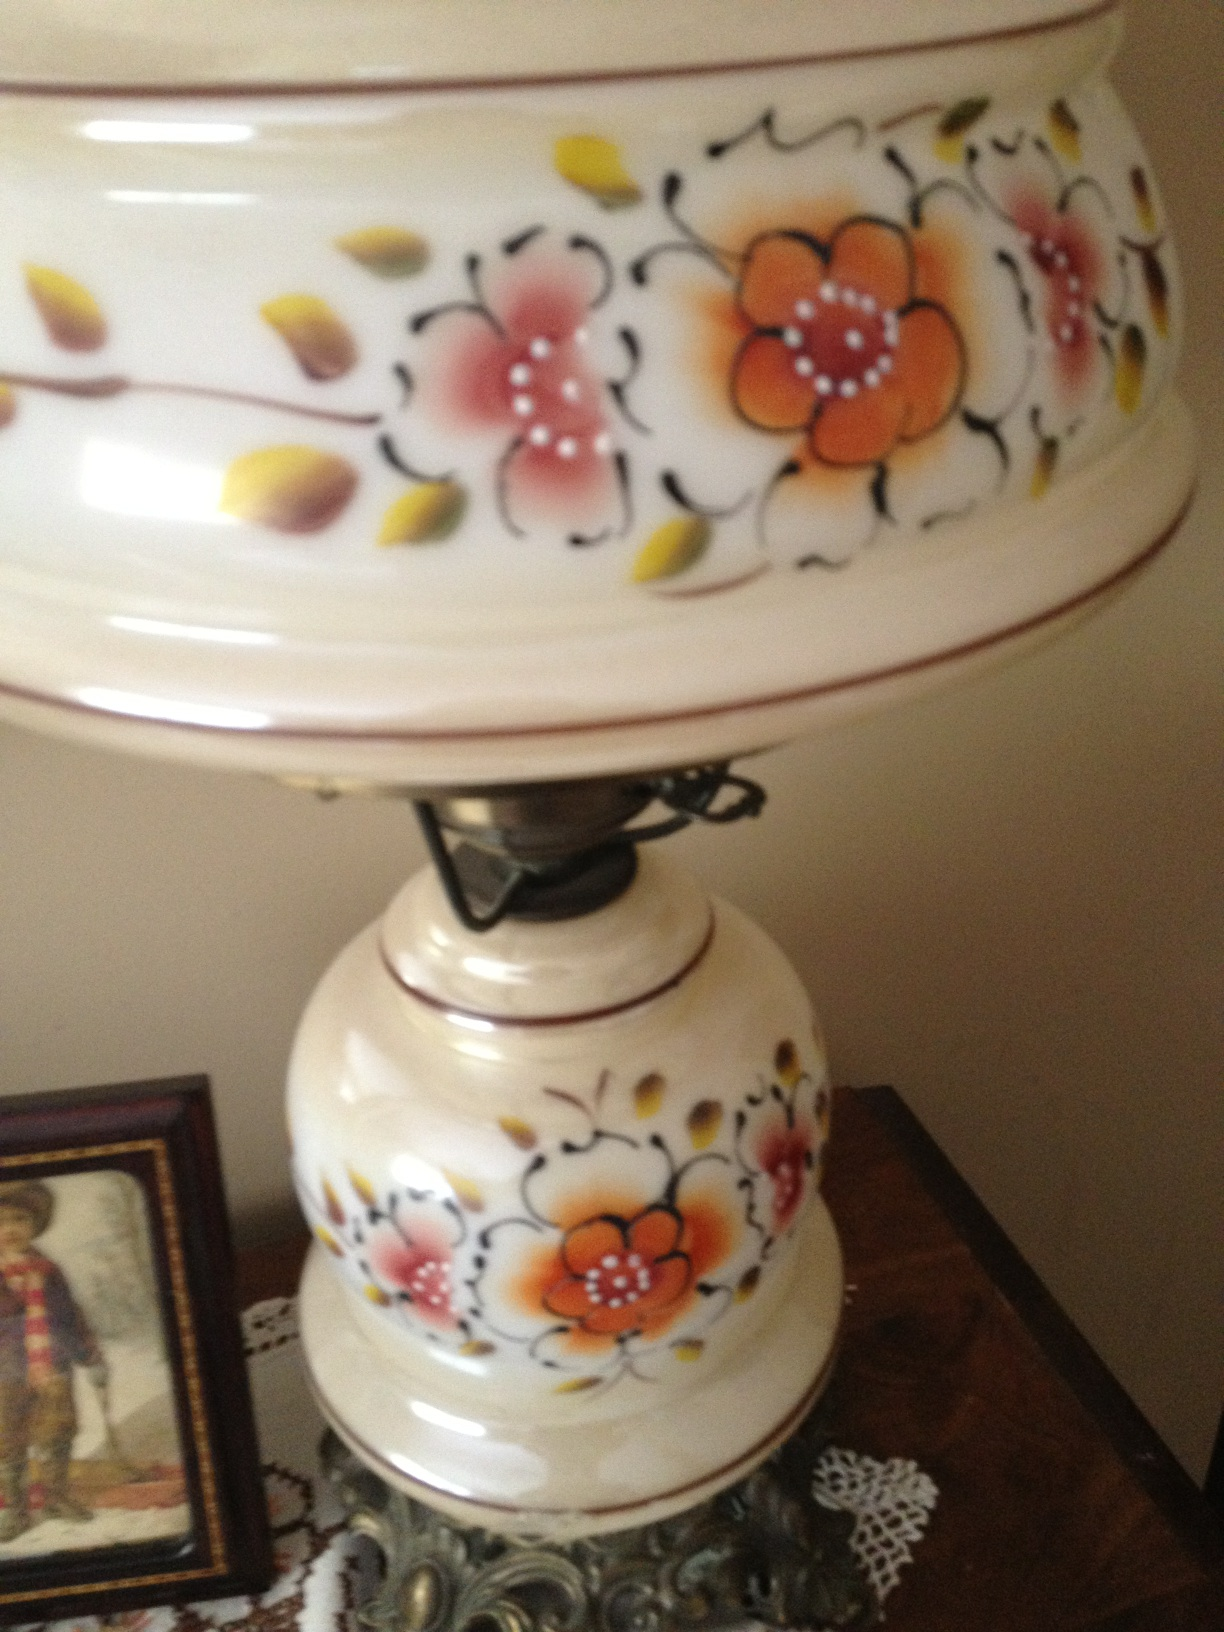What is this? This appears to be a large, decorative ceramic item, possibly a tea urn, featuring a colorful floral design. It is likely used for serving tea and could be a significant item in traditional tea ceremonies or gatherings, enhancing the aesthetic appeal of the setting. 